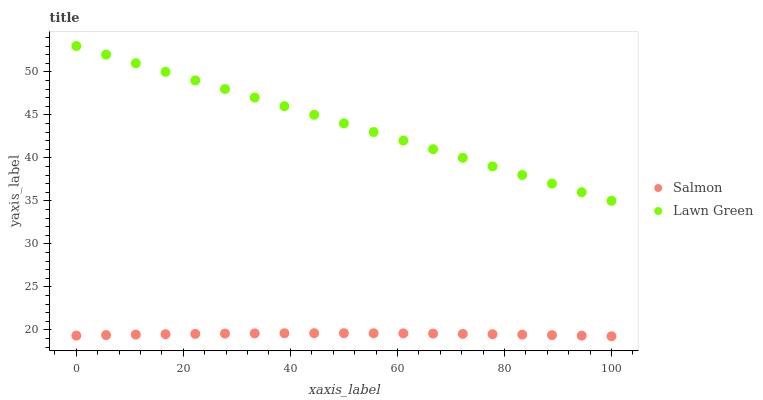Does Salmon have the minimum area under the curve?
Answer yes or no. Yes. Does Lawn Green have the maximum area under the curve?
Answer yes or no. Yes. Does Salmon have the maximum area under the curve?
Answer yes or no. No. Is Lawn Green the smoothest?
Answer yes or no. Yes. Is Salmon the roughest?
Answer yes or no. Yes. Is Salmon the smoothest?
Answer yes or no. No. Does Salmon have the lowest value?
Answer yes or no. Yes. Does Lawn Green have the highest value?
Answer yes or no. Yes. Does Salmon have the highest value?
Answer yes or no. No. Is Salmon less than Lawn Green?
Answer yes or no. Yes. Is Lawn Green greater than Salmon?
Answer yes or no. Yes. Does Salmon intersect Lawn Green?
Answer yes or no. No. 